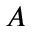Convert formula to latex. <formula><loc_0><loc_0><loc_500><loc_500>A</formula> 